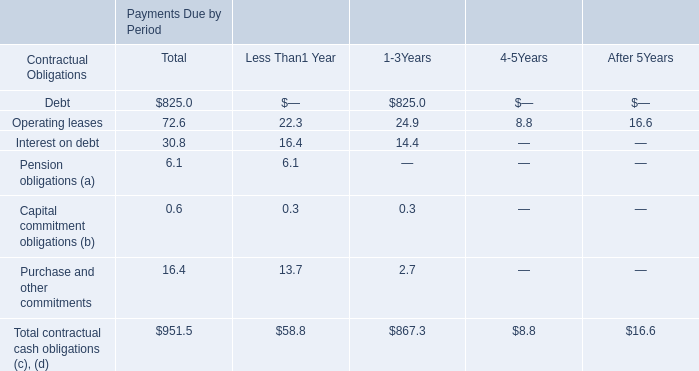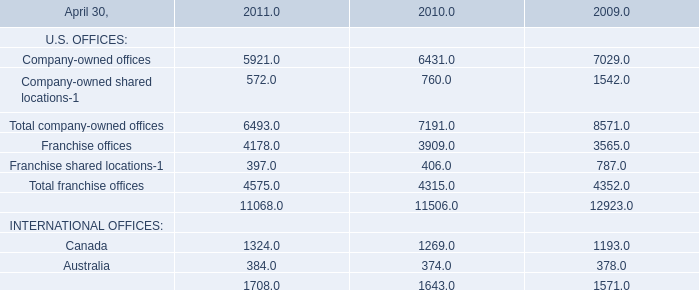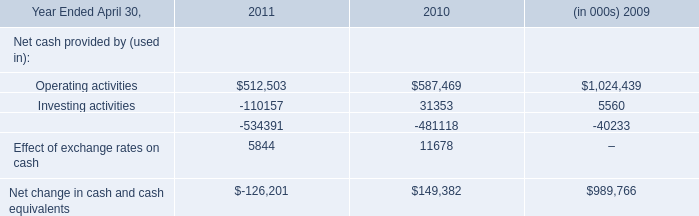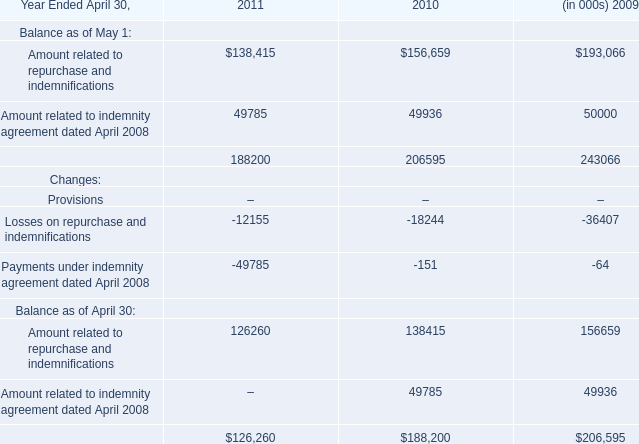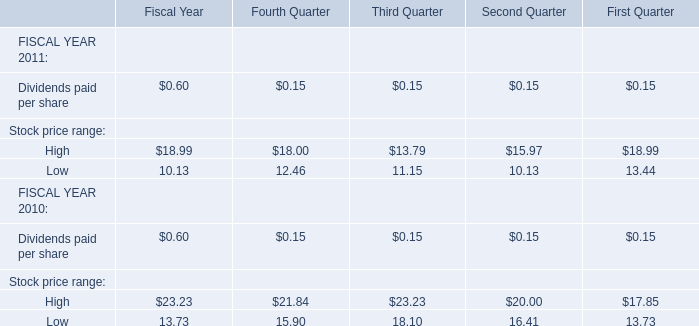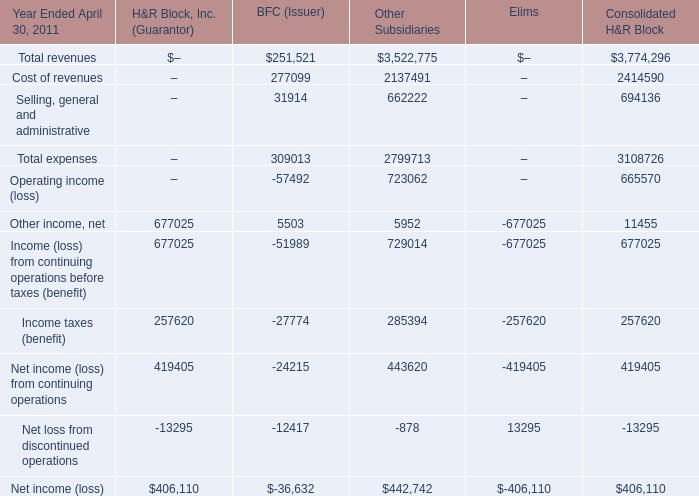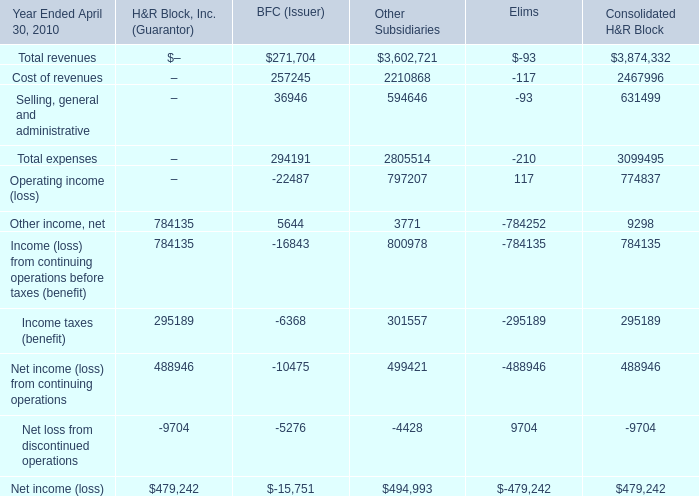What is the sum of the Income taxes (benefit) in the years where Other income, net is positive? 
Computations: ((295189 - 6368) + 301557)
Answer: 590378.0. 